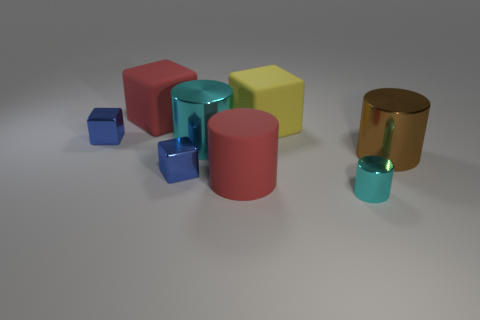The metallic cube on the left side of the big matte object behind the big yellow rubber object is what color?
Offer a terse response. Blue. There is a matte cylinder that is the same size as the yellow rubber thing; what is its color?
Your response must be concise. Red. How many yellow things are right of the big shiny cylinder to the right of the tiny cyan cylinder?
Make the answer very short. 0. What size is the other shiny cylinder that is the same color as the small metallic cylinder?
Your answer should be very brief. Large. What number of things are big red cylinders or small metal blocks to the right of the big red cube?
Keep it short and to the point. 2. Is there a large cylinder that has the same material as the red block?
Keep it short and to the point. Yes. What number of cylinders are to the right of the big cyan metallic cylinder and behind the small cyan metallic cylinder?
Keep it short and to the point. 2. What is the small thing that is behind the big brown thing made of?
Ensure brevity in your answer.  Metal. There is a yellow thing that is the same material as the red cylinder; what size is it?
Ensure brevity in your answer.  Large. There is a large yellow object; are there any cyan objects right of it?
Ensure brevity in your answer.  Yes. 